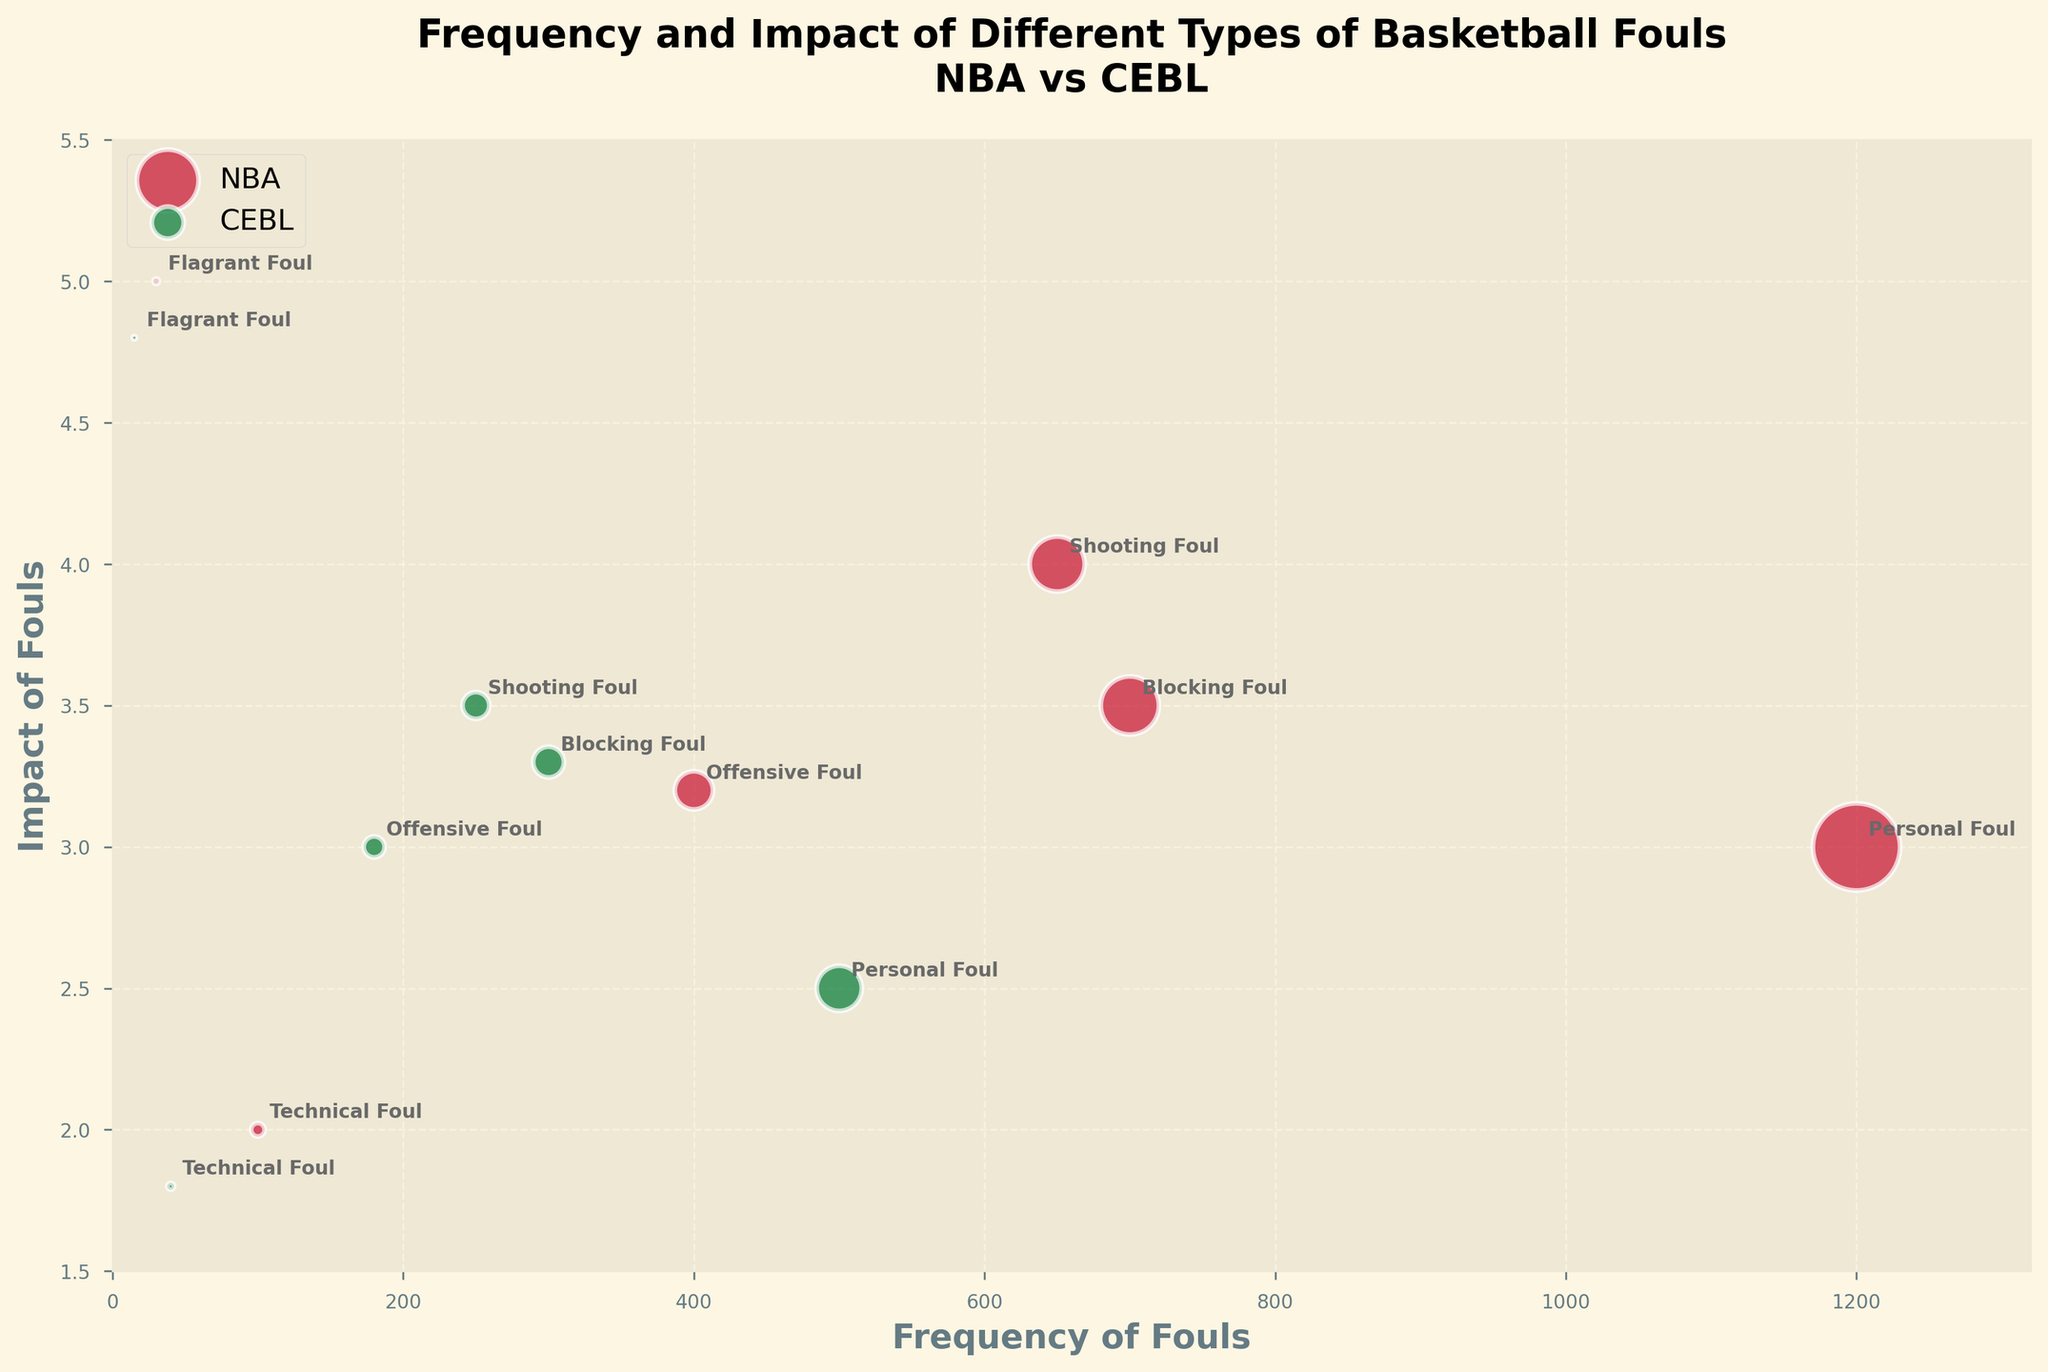What's the title of the figure? The title is displayed at the top of the figure in larger bold text. The title summarizes what the plot is about.
Answer: Frequency and Impact of Different Types of Basketball Fouls in NBA vs CEBL What is the color used for NBA data points? The color for NBA data points is different from CEBL data points, visually distinguishable in the plot. The legend indicates that NBA data points are red.
Answer: Red Which foul type has the highest impact in NBA games? By looking at the vertical position of each bubble, identify which is the highest on the impact axis. The flagrant foul bubble is at the top in the NBA section.
Answer: Flagrant Foul Compare the frequency of Shooting Fouls in NBA and CEBL. Which is more frequent? By comparing the horizontal position of the Shooting Foul bubbles for both NBA and CEBL, it is apparent that the NBA bubble is farther to the right, indicating a higher frequency.
Answer: NBA What is the impact of Technical Fouls in CEBL? Look at the vertical position of the Technical Foul bubble for CEBL on the impact axis. It is positioned slightly below 2.
Answer: 1.8 How does the frequency of Personal Fouls in NBA compare to that in CEBL? The Personal Foul bubbles can be compared. The NBA bubble is much farther to the right on the frequency axis than the CEBL bubble.
Answer: NBA has a higher frequency What is the smallest bubble in the chart, and what does it represent? The smallest bubble can be identified by its size. The smallest appears to be the Flagrant Foul in the CEBL, represented by a smaller circle.
Answer: Flagrant Foul in CEBL Do blocking fouls have a higher impact in NBA or CEBL? Compare the vertical position of the Blocking Foul bubbles. The NBA bubble is slightly higher than the CEBL bubble.
Answer: NBA Which foul types appear on the plot for NBA but not for CEBL? All foul types are named in the plot. By checking both sides, all foul types appear to be shared, no unique types solely for one league.
Answer: All foul types appear in both leagues What is the most impactful foul overall and in which league does it occur? By comparing the highest positioned bubbles on the impact axis for both leagues, the Flagrant Foul in NBA tops the plot.
Answer: Flagrant Foul in NBA 